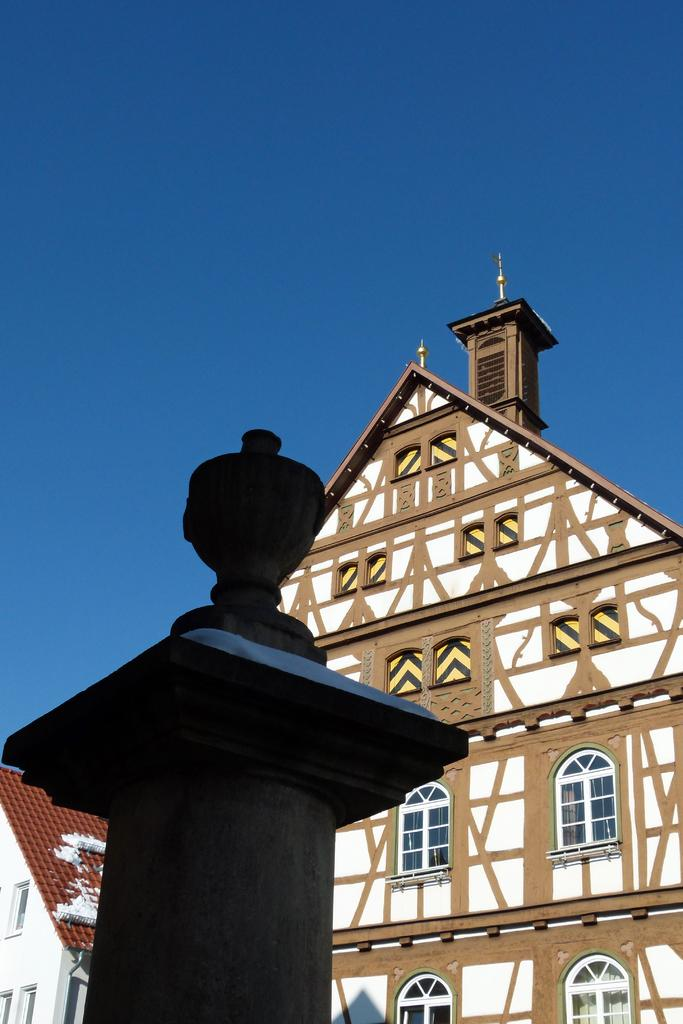What is the main object in the image? There is a pole in the image. What type of structures can be seen in the image? There are buildings with windows in the image. What can be seen in the background of the image? The blue sky is visible in the background of the image. How many boys are playing in the jail in the image? There are no boys or jails present in the image; it features a pole and buildings with windows. 